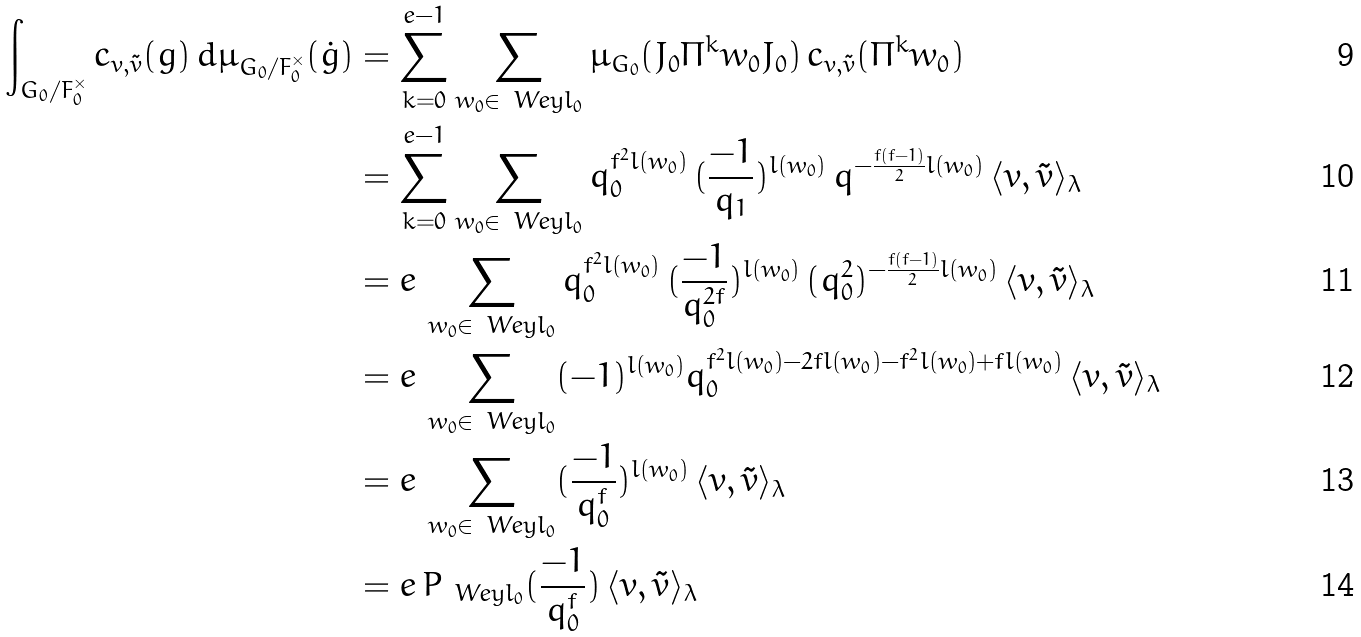Convert formula to latex. <formula><loc_0><loc_0><loc_500><loc_500>\int _ { G _ { 0 } / F _ { 0 } ^ { \times } } c _ { v , { \tilde { v } } } ( g ) \, d \mu _ { G _ { 0 } / F _ { 0 } ^ { \times } } ( { \dot { g } } ) & = \sum _ { k = 0 } ^ { e - 1 } \sum _ { w _ { 0 } \in \ W e y l _ { 0 } } \mu _ { G _ { 0 } } ( J _ { 0 } \Pi ^ { k } w _ { 0 } J _ { 0 } ) \, c _ { v , { \tilde { v } } } ( \Pi ^ { k } w _ { 0 } ) \\ & = \sum _ { k = 0 } ^ { e - 1 } \sum _ { w _ { 0 } \in \ W e y l _ { 0 } } q _ { 0 } ^ { f ^ { 2 } l ( w _ { 0 } ) } \, ( \frac { - 1 } { q _ { 1 } } ) ^ { l ( w _ { 0 } ) } \, q ^ { - \frac { f ( f - 1 ) } { 2 } l ( w _ { 0 } ) } \, \langle v , { \tilde { v } } \rangle _ { \lambda } \\ & = e \, \sum _ { w _ { 0 } \in \ W e y l _ { 0 } } q _ { 0 } ^ { f ^ { 2 } l ( w _ { 0 } ) } \, ( \frac { - 1 } { q _ { 0 } ^ { 2 f } } ) ^ { l ( w _ { 0 } ) } \, ( q _ { 0 } ^ { 2 } ) ^ { - \frac { f ( f - 1 ) } { 2 } l ( w _ { 0 } ) } \, \langle v , { \tilde { v } } \rangle _ { \lambda } \\ & = e \, \sum _ { w _ { 0 } \in \ W e y l _ { 0 } } ( - 1 ) ^ { l ( w _ { 0 } ) } q _ { 0 } ^ { f ^ { 2 } l ( w _ { 0 } ) - 2 f l ( w _ { 0 } ) - f ^ { 2 } l ( w _ { 0 } ) + f l ( w _ { 0 } ) } \, \langle v , { \tilde { v } } \rangle _ { \lambda } \\ & = e \, \sum _ { w _ { 0 } \in \ W e y l _ { 0 } } ( \frac { - 1 } { q _ { 0 } ^ { f } } ) ^ { l ( w _ { 0 } ) } \, \langle v , { \tilde { v } } \rangle _ { \lambda } \\ & = e \, P _ { \ W e y l _ { 0 } } ( \frac { - 1 } { q _ { 0 } ^ { f } } ) \, \langle v , { \tilde { v } } \rangle _ { \lambda }</formula> 